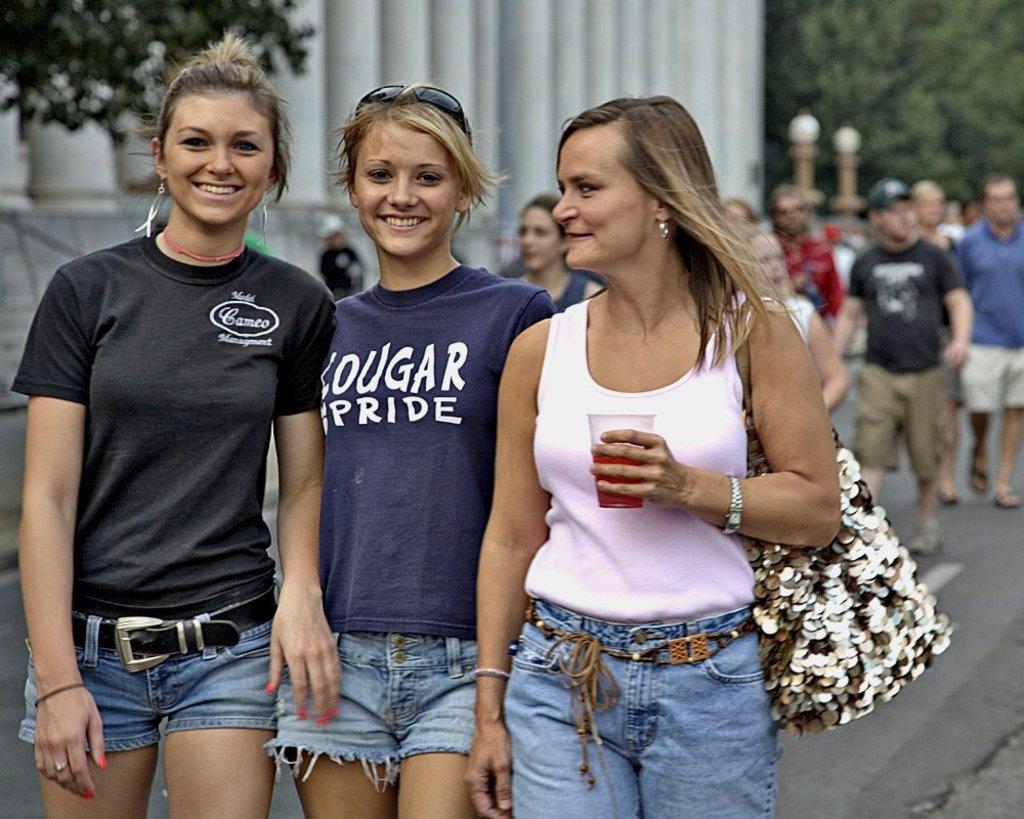How would you summarize this image in a sentence or two? In this image there are three persons standing , group of people walking on the road, building, trees. 